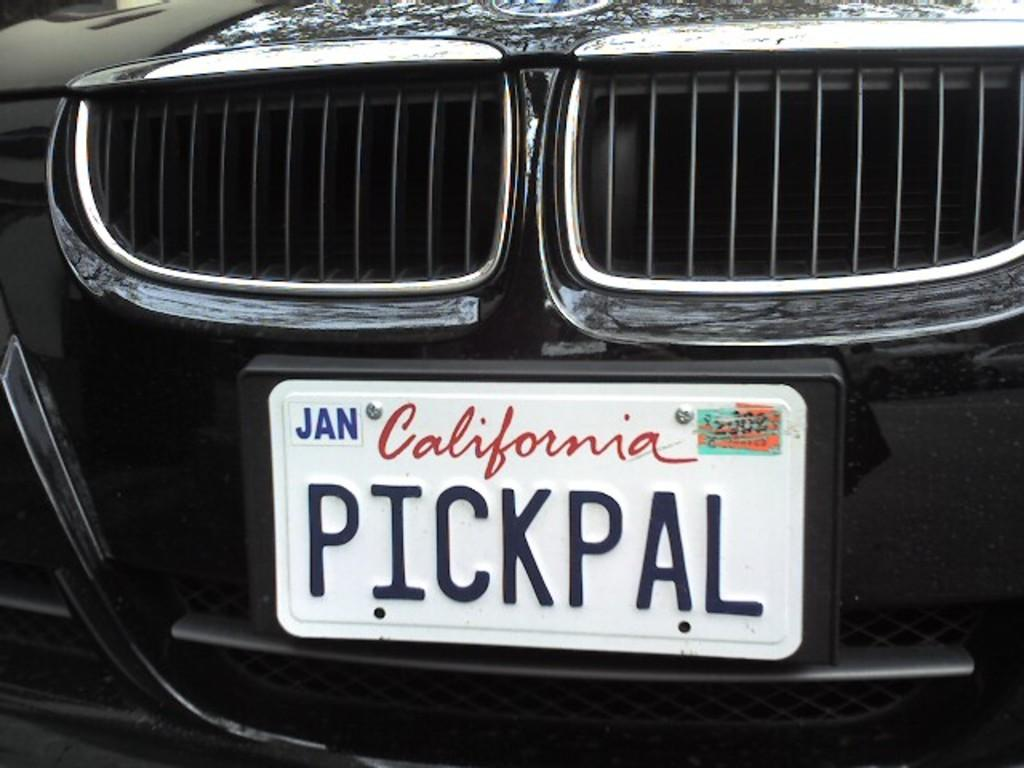<image>
Relay a brief, clear account of the picture shown. PickPal is the nickname of a driver in California. 